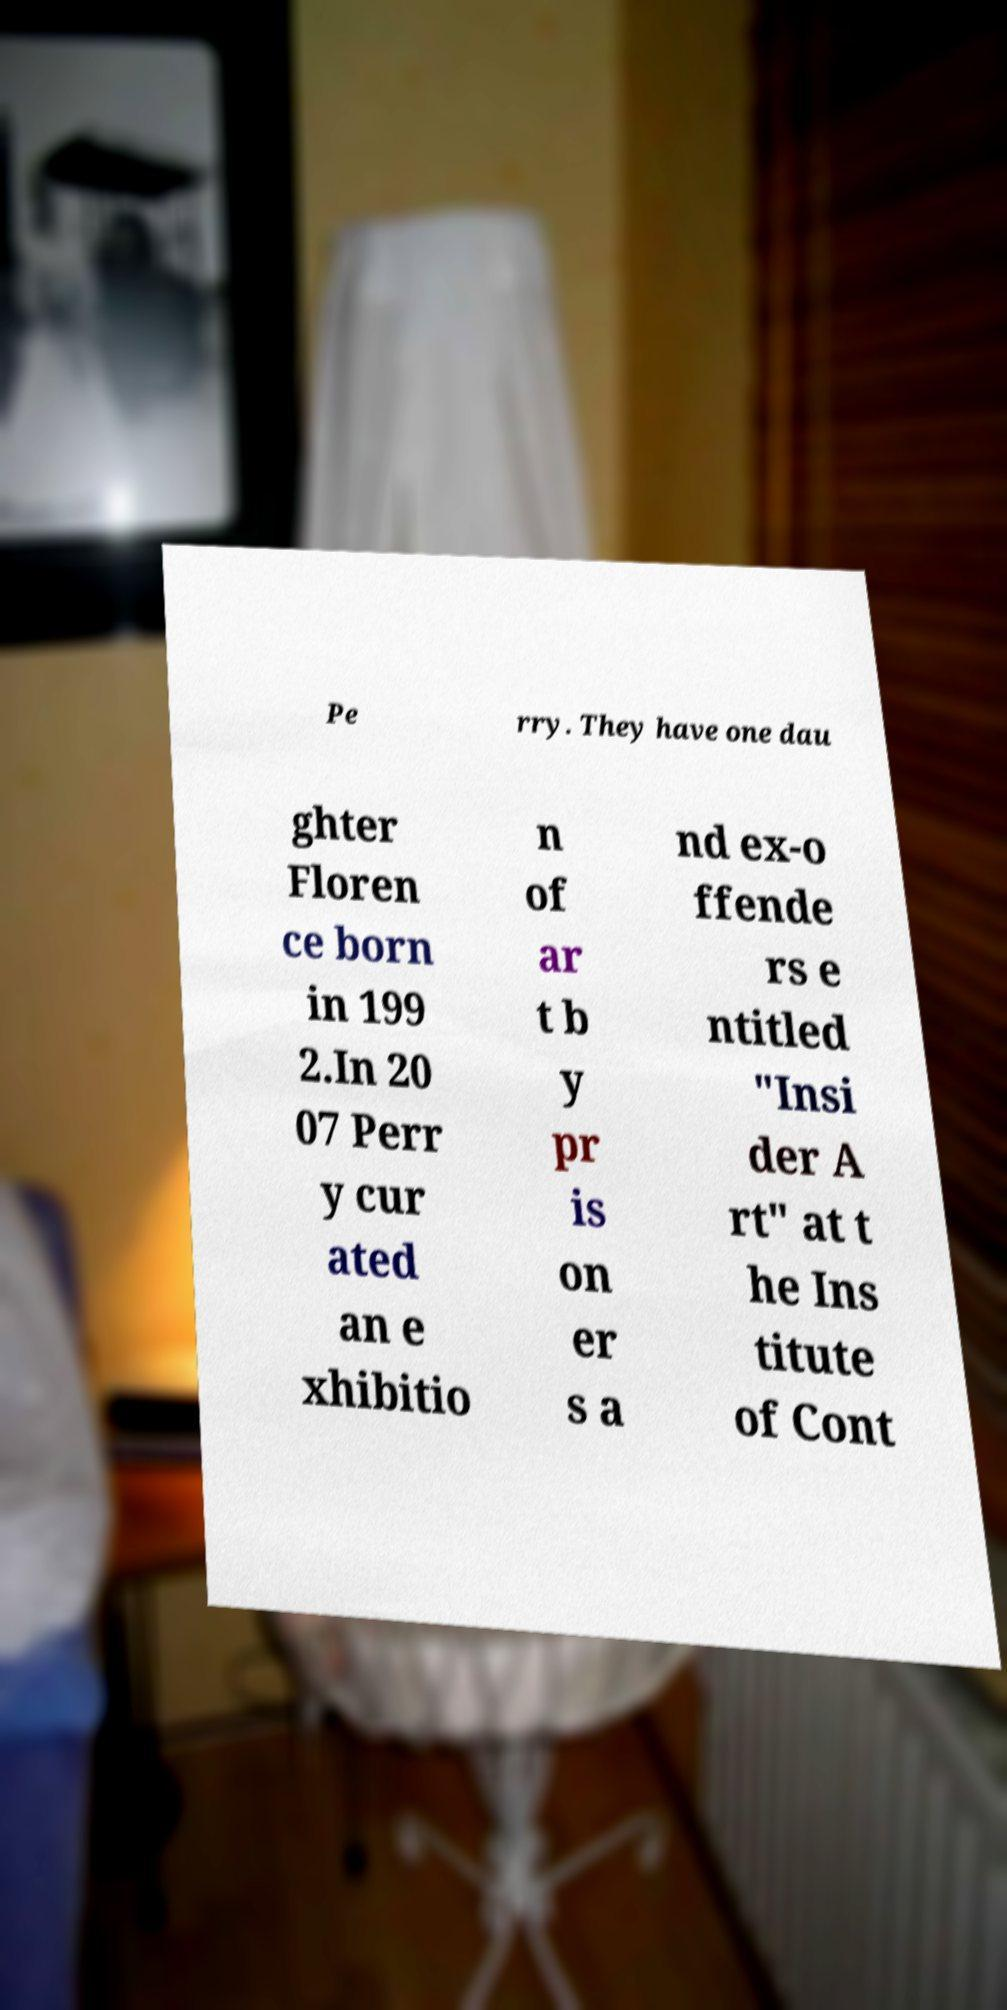Please read and relay the text visible in this image. What does it say? Pe rry. They have one dau ghter Floren ce born in 199 2.In 20 07 Perr y cur ated an e xhibitio n of ar t b y pr is on er s a nd ex-o ffende rs e ntitled "Insi der A rt" at t he Ins titute of Cont 